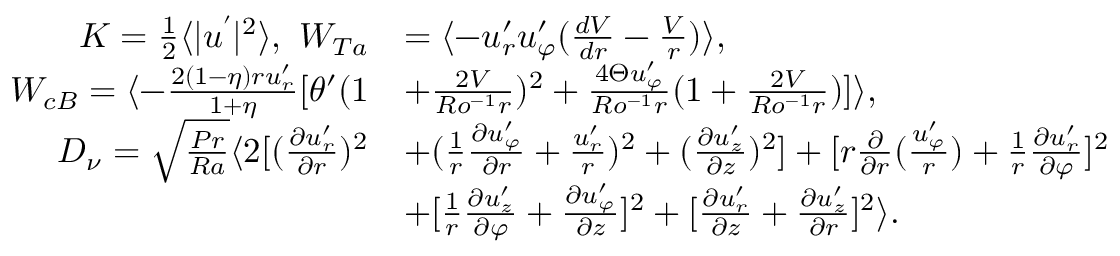<formula> <loc_0><loc_0><loc_500><loc_500>\begin{array} { r l } { K = \frac { 1 } { 2 } \langle | u ^ { \prime } | ^ { 2 } \rangle , \ W _ { T a } } & { = \langle - u _ { r } ^ { \prime } u _ { \varphi } ^ { \prime } ( \frac { d V } { d r } - \frac { V } { r } ) \rangle , } \\ { W _ { c B } = \langle - \frac { 2 ( 1 - \eta ) r u _ { r } ^ { \prime } } { 1 + \eta } [ \theta ^ { \prime } ( 1 } & { + \frac { 2 V } { R o ^ { - 1 } r } ) ^ { 2 } + \frac { 4 \Theta u _ { \varphi } ^ { \prime } } { R o ^ { - 1 } r } ( 1 + \frac { 2 V } { R o ^ { - 1 } r } ) ] \rangle , } \\ { D _ { \nu } = \sqrt { \frac { P r } { R a } } \langle 2 [ ( \frac { \partial u _ { r } ^ { \prime } } { \partial r } ) ^ { 2 } } & { + ( \frac { 1 } { r } \frac { \partial u _ { \varphi } ^ { \prime } } { \partial { r } } + \frac { u _ { r } ^ { \prime } } { r } ) ^ { 2 } + ( \frac { \partial u _ { z } ^ { \prime } } { \partial z } ) ^ { 2 } ] + [ r \frac { \partial } { \partial r } ( \frac { u _ { \varphi } ^ { \prime } } { r } ) + \frac { 1 } { r } \frac { \partial u _ { r } ^ { \prime } } { \partial \varphi } ] ^ { 2 } } \\ & { + [ \frac { 1 } { r } \frac { \partial u _ { z } ^ { \prime } } { \partial \varphi } + \frac { \partial u _ { \varphi } ^ { \prime } } { \partial z } ] ^ { 2 } + [ \frac { \partial u _ { r } ^ { \prime } } { \partial z } + \frac { \partial u _ { z } ^ { \prime } } { \partial r } ] ^ { 2 } \rangle . } \end{array}</formula> 